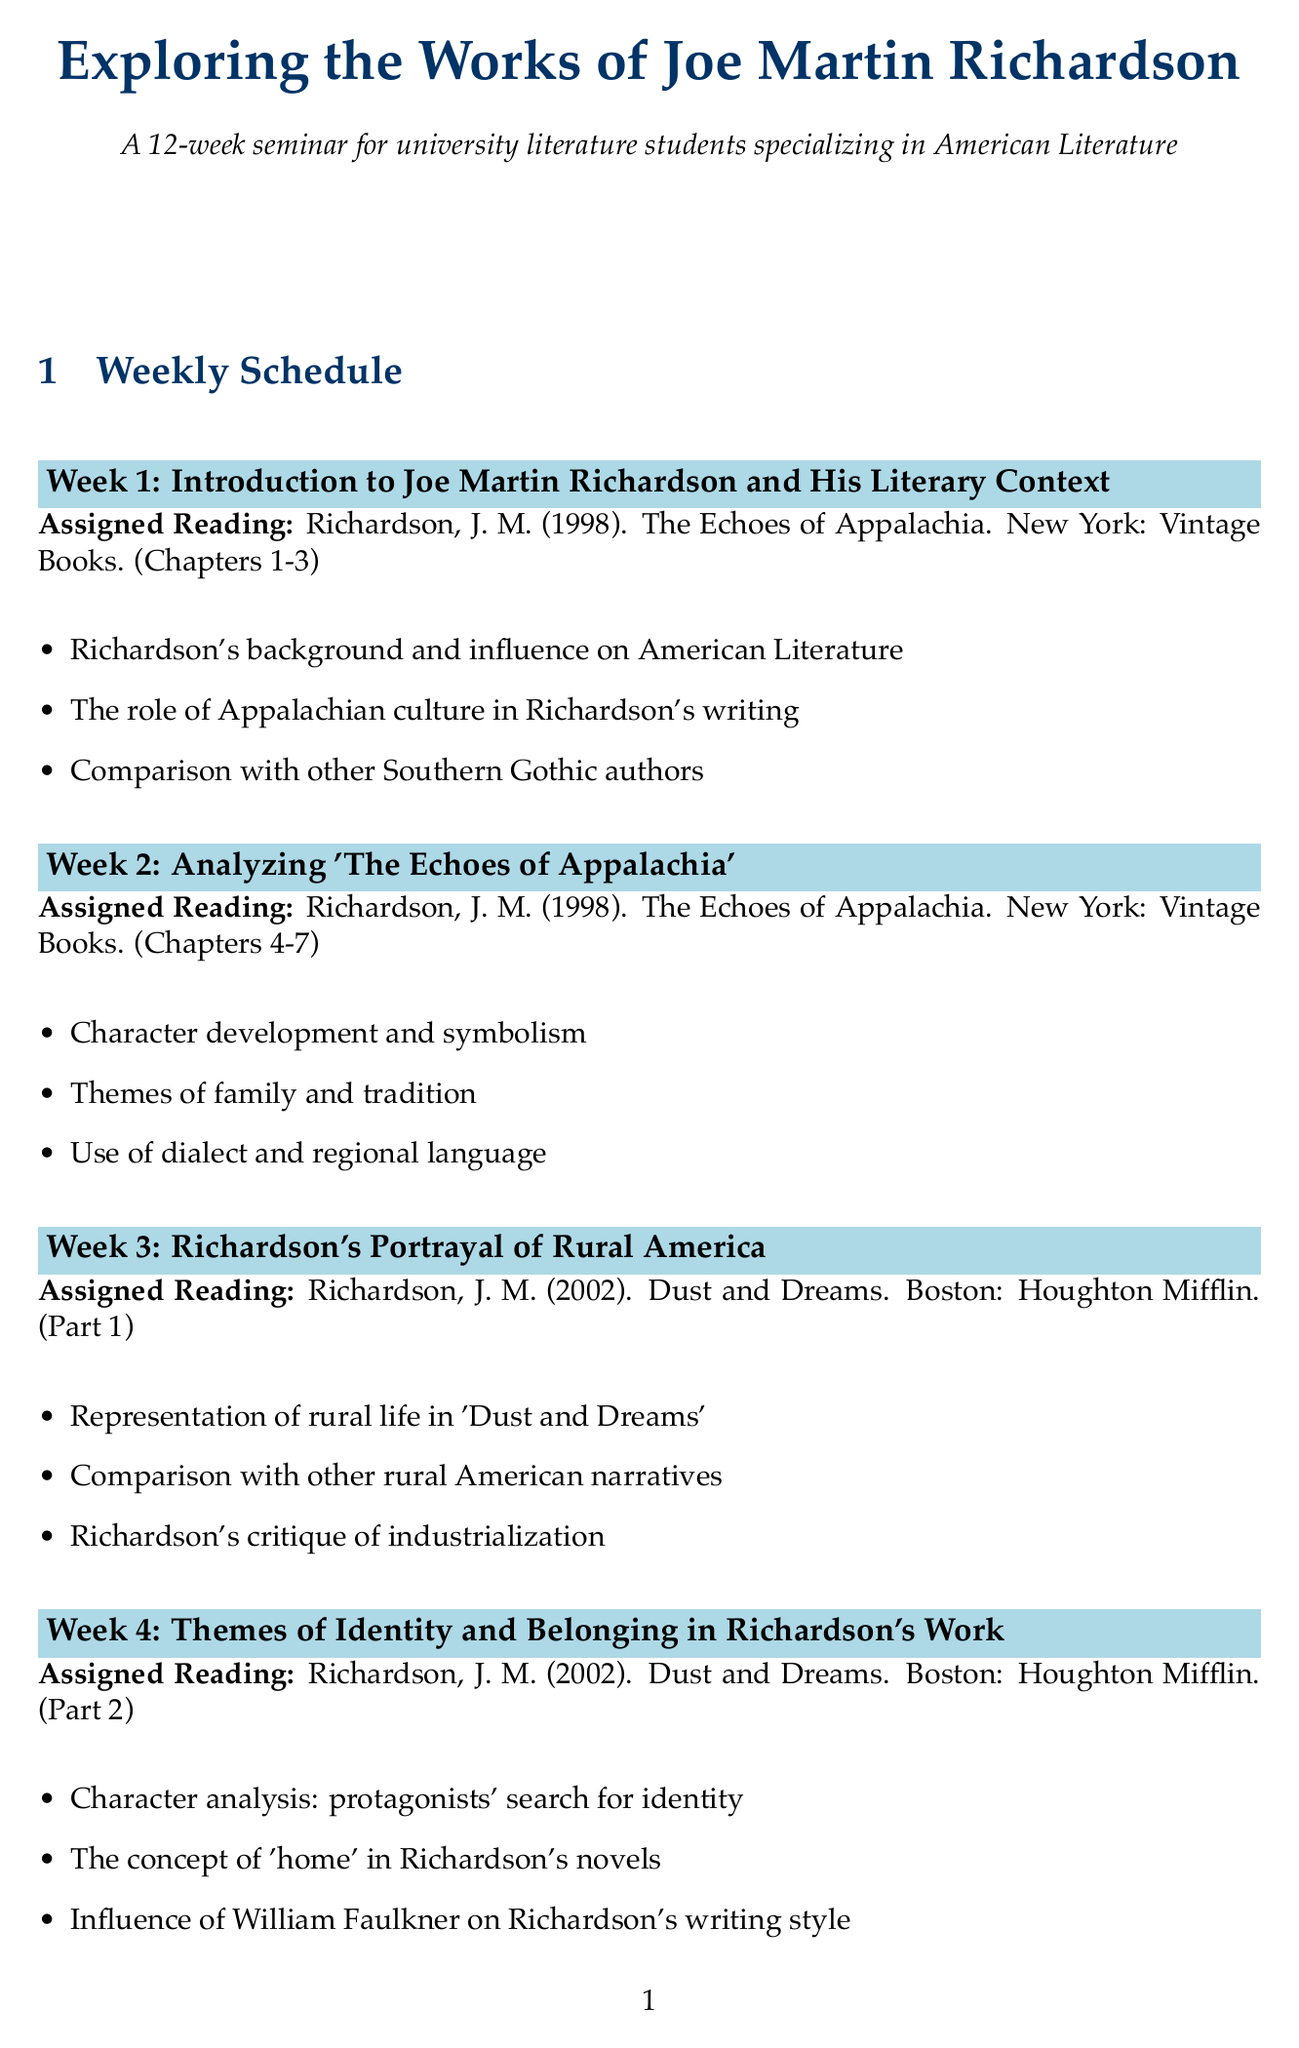What is the title of the seminar? The title of the seminar is the first line in the document, which clearly states it.
Answer: Exploring the Works of Joe Martin Richardson How many weeks does the seminar last? The duration is mentioned in the introduction, indicating the total count of sessions.
Answer: 12 weeks What is the assigned reading for Week 2? This information is detailed under the "Assigned Reading" section for Week 2 in the schedule.
Answer: Richardson, J. M. (1998). The Echoes of Appalachia. New York: Vintage Books. (Chapters 4-7) What are the discussion points for Week 6? The discussion points are listed under Week 6, providing specific focus areas for that week.
Answer: Natural symbolism in 'River's Edge', Eco-critical approach to Richardson's work, Comparison with Annie Dillard's nature writing Which novel is analyzed in Week 4? The topic assigned for Week 4 gives specifics about the literary work discussed that week.
Answer: Dust and Dreams What theme is explored in Week 8? The theme is clearly stated in the topic of Week 8, which highlights the focus for that session.
Answer: Gender and Sexuality in Richardson's Novels The assigned reading for Week 11 consists of which chapters? The specific chapters assigned for the reading are listed under Week 11, confirming the textual material for discussion.
Answer: Chapters 6-10 How does Richardson approach historical fiction according to Week 7? This information can be inferred from the topic title of Week 7, pointing toward his method in literary works.
Answer: Historical events incorporation What is the focus of discussions in Week 12? The discussions in Week 12 are summarized in the "discussion points" section for that week.
Answer: Overall themes and motifs in Richardson's body of work, Richardson's contribution to American Literature, Future directions for Richardson scholarship 